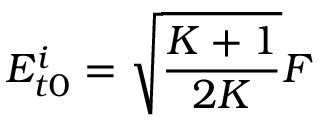<formula> <loc_0><loc_0><loc_500><loc_500>E _ { t 0 } ^ { i } = \sqrt { \frac { K + 1 } { 2 K } } F</formula> 